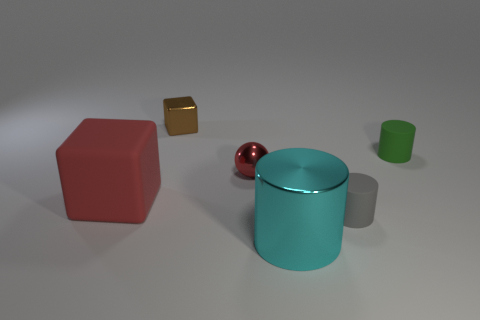Subtract all cyan cylinders. How many cylinders are left? 2 Subtract all red cubes. How many cubes are left? 1 Add 3 large red matte cubes. How many objects exist? 9 Subtract all spheres. How many objects are left? 5 Subtract 1 cylinders. How many cylinders are left? 2 Add 5 big cubes. How many big cubes are left? 6 Add 4 gray matte objects. How many gray matte objects exist? 5 Subtract 1 cyan cylinders. How many objects are left? 5 Subtract all green balls. Subtract all green cylinders. How many balls are left? 1 Subtract all large gray shiny balls. Subtract all small red spheres. How many objects are left? 5 